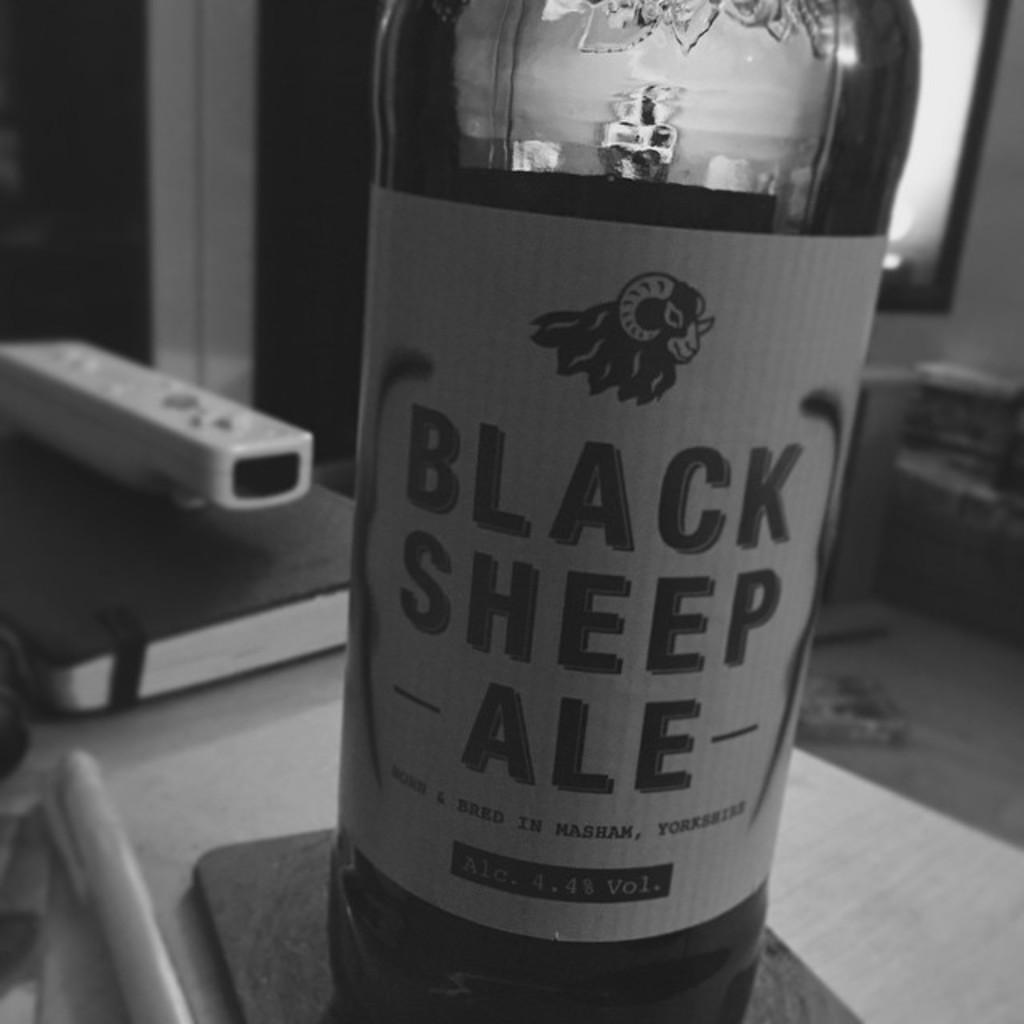<image>
Describe the image concisely. A bottle of Black Sheep Ale is on a table 